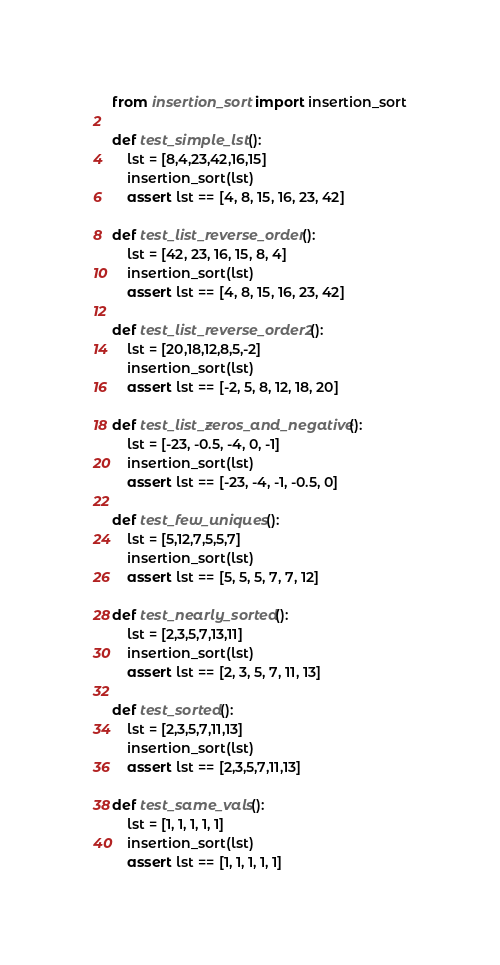<code> <loc_0><loc_0><loc_500><loc_500><_Python_>from insertion_sort import insertion_sort

def test_simple_lst():
    lst = [8,4,23,42,16,15]
    insertion_sort(lst)
    assert lst == [4, 8, 15, 16, 23, 42]

def test_list_reverse_order():
    lst = [42, 23, 16, 15, 8, 4]
    insertion_sort(lst)
    assert lst == [4, 8, 15, 16, 23, 42]

def test_list_reverse_order2():
    lst = [20,18,12,8,5,-2]
    insertion_sort(lst)
    assert lst == [-2, 5, 8, 12, 18, 20]

def test_list_zeros_and_negative():
    lst = [-23, -0.5, -4, 0, -1]
    insertion_sort(lst)
    assert lst == [-23, -4, -1, -0.5, 0]

def test_few_uniques():
    lst = [5,12,7,5,5,7]
    insertion_sort(lst)
    assert lst == [5, 5, 5, 7, 7, 12]

def test_nearly_sorted():
    lst = [2,3,5,7,13,11]
    insertion_sort(lst)
    assert lst == [2, 3, 5, 7, 11, 13]

def test_sorted():
    lst = [2,3,5,7,11,13]
    insertion_sort(lst)
    assert lst == [2,3,5,7,11,13]

def test_same_vals():
    lst = [1, 1, 1, 1, 1]
    insertion_sort(lst)
    assert lst == [1, 1, 1, 1, 1]

</code> 